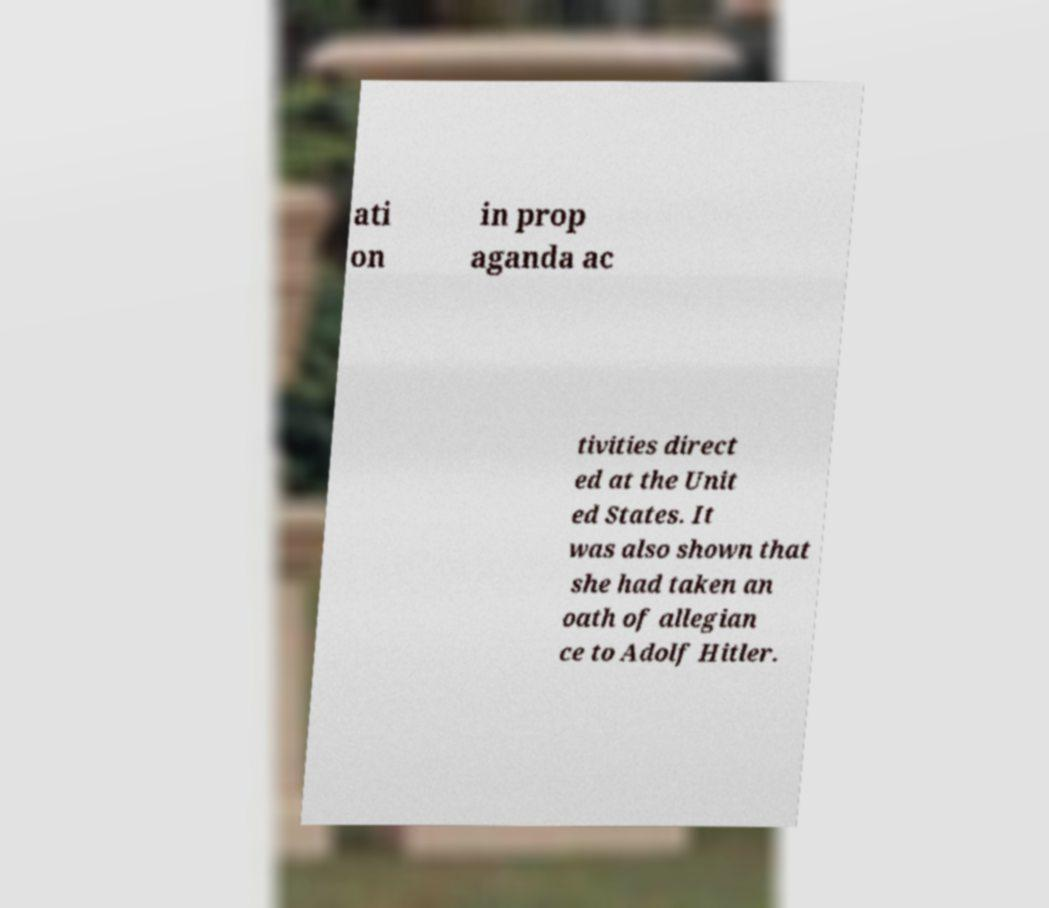I need the written content from this picture converted into text. Can you do that? ati on in prop aganda ac tivities direct ed at the Unit ed States. It was also shown that she had taken an oath of allegian ce to Adolf Hitler. 